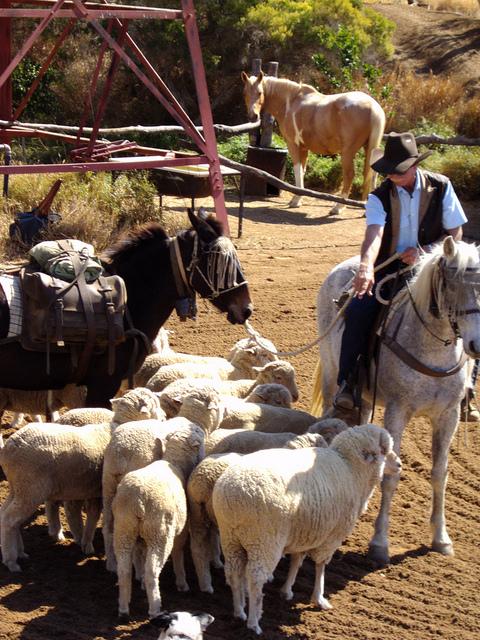What are the people herding?
Give a very brief answer. Sheep. What is the horse wearing on it's face?
Write a very short answer. Blinders. What are the colors of the horses?
Answer briefly. White, brown, tan. 